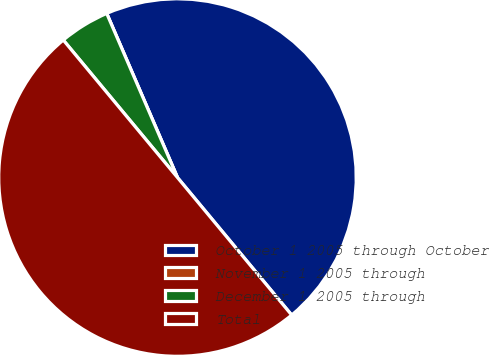Convert chart. <chart><loc_0><loc_0><loc_500><loc_500><pie_chart><fcel>October 1 2005 through October<fcel>November 1 2005 through<fcel>December 1 2005 through<fcel>Total<nl><fcel>45.45%<fcel>0.0%<fcel>4.55%<fcel>50.0%<nl></chart> 